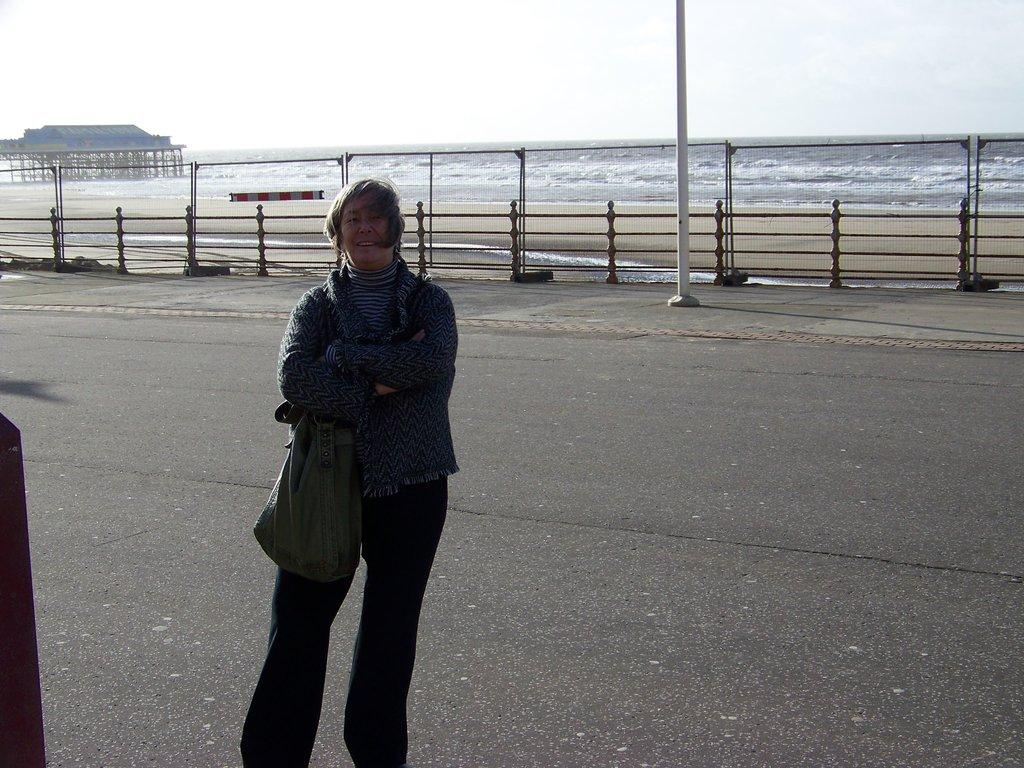What is the person in the image doing? The person is standing on the road. What is the person carrying or wearing? The person is wearing a bag. What can be seen in the background of the image? There is a fence in the image. What is visible in the image besides the person and the fence? There is water visible in the image. How does the person pull the car in the image? There is no car present in the image, so the person cannot pull a car. 